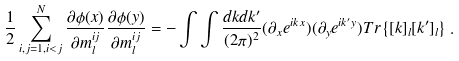<formula> <loc_0><loc_0><loc_500><loc_500>\frac { 1 } { 2 } \sum _ { i , j = 1 , i < j } ^ { N } \frac { \partial \phi ( x ) } { \partial m ^ { i j } _ { l } } \frac { \partial \phi ( y ) } { \partial m ^ { i j } _ { l } } = - \int \int \frac { d k d k ^ { \prime } } { ( 2 \pi ) ^ { 2 } } ( \partial _ { x } e ^ { i k x } ) ( \partial _ { y } e ^ { i k ^ { \prime } y } ) T r \left \{ [ k ] _ { l } [ k ^ { \prime } ] _ { l } \right \} \, .</formula> 